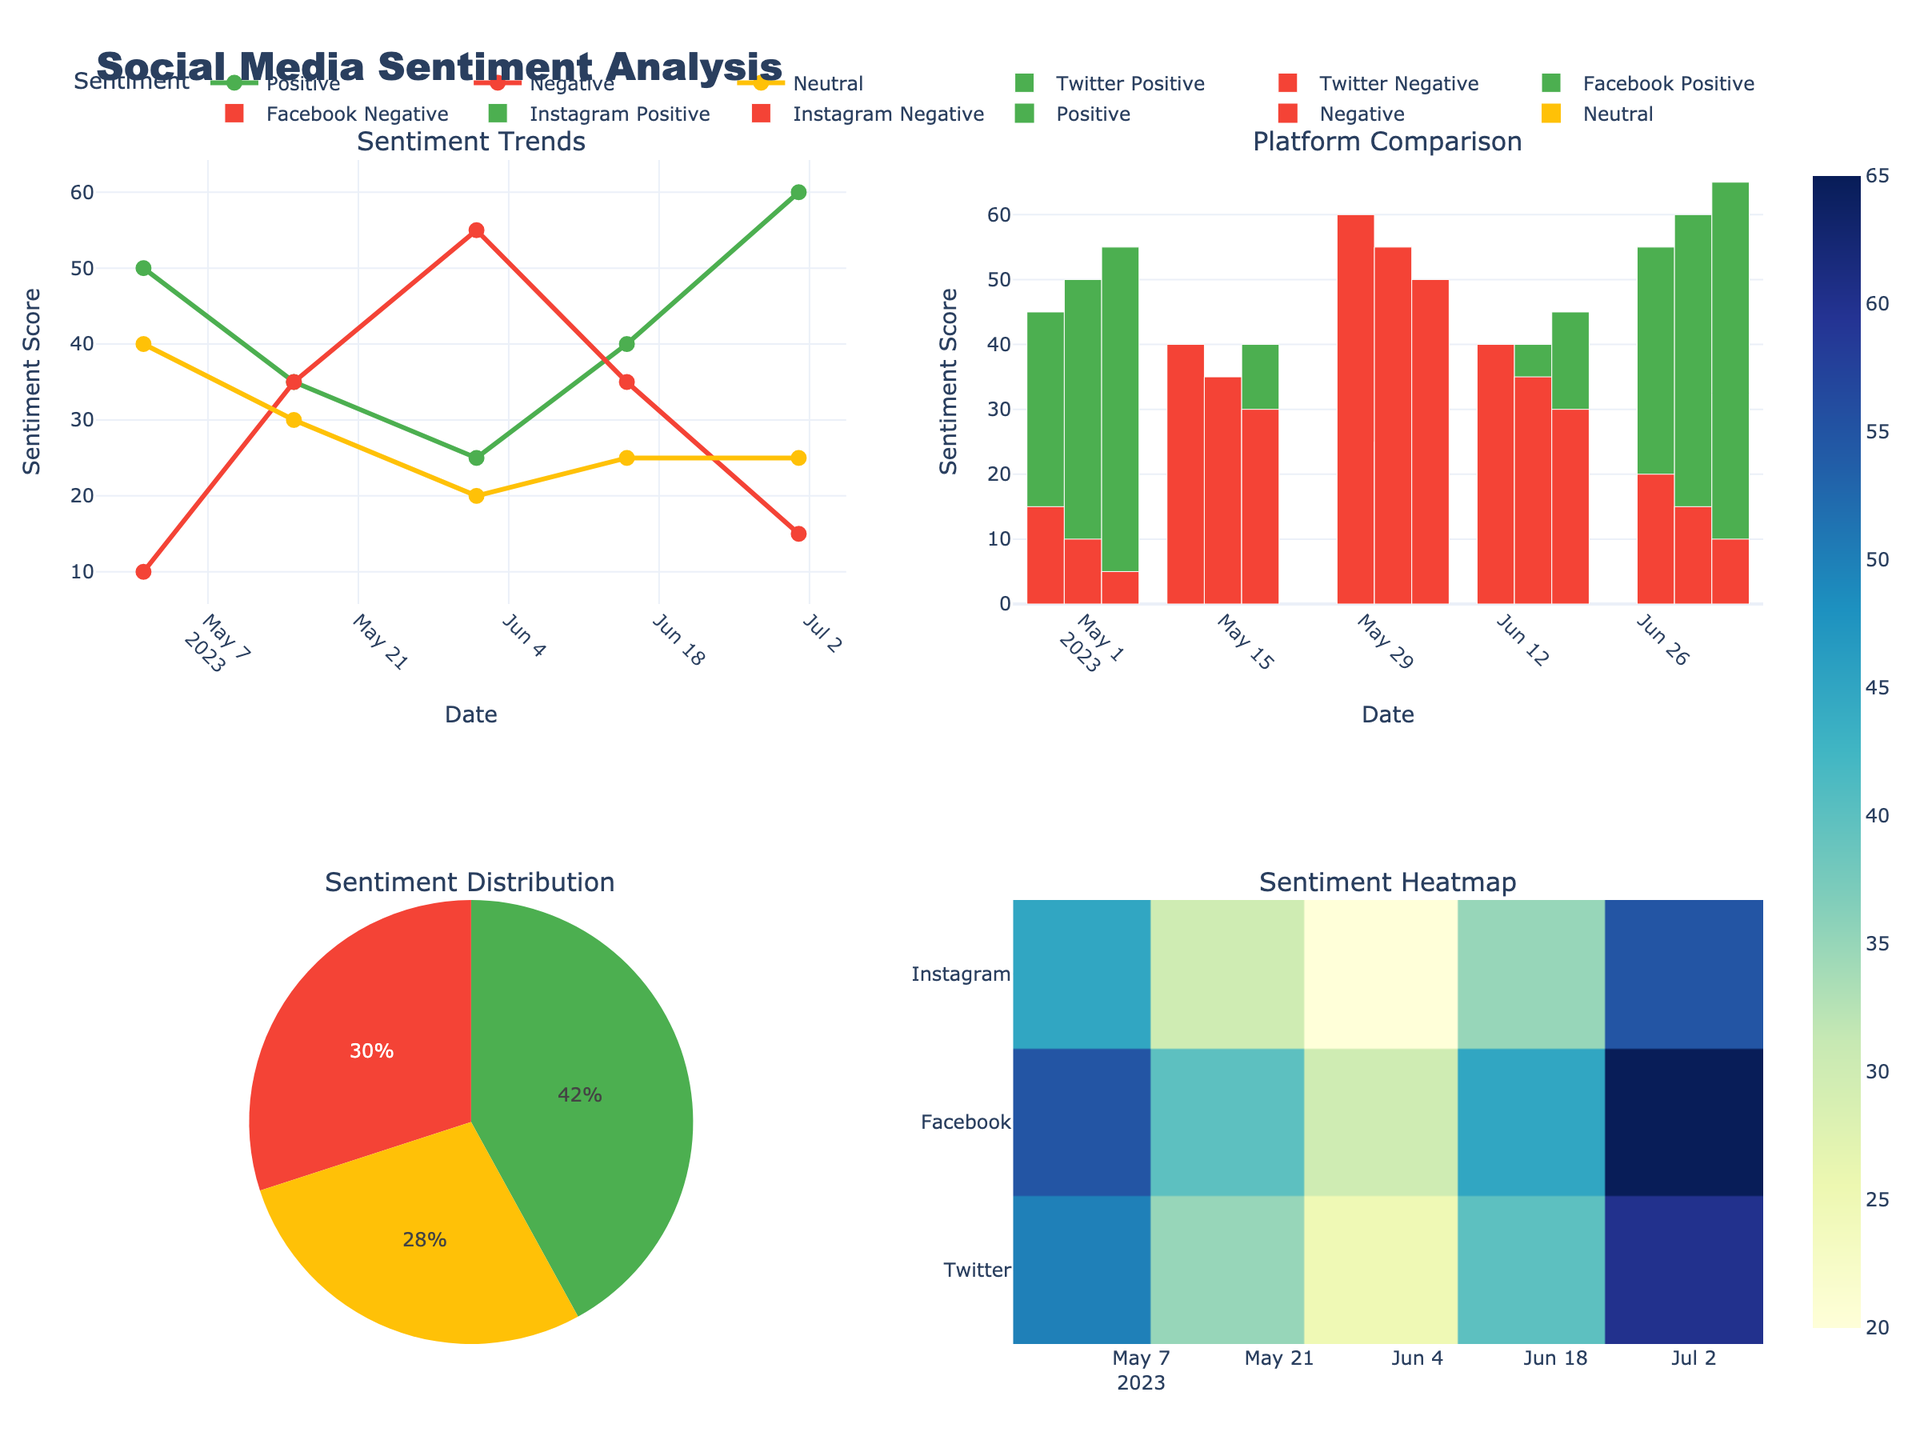What is the title of the chart? The title of the chart is placed at the top-center position and uses large, bold font for visibility.
Answer: Social Media Sentiment Analysis Which platform shows the highest positive sentiment on July 1st? Look at the grouped bar chart in the upper right corner and locate the bars corresponding to July 1st. The highest positive sentiment is indicated by the tallest blue bar among the platforms.
Answer: Instagram How did the negative sentiment on Twitter change from May 1st to June 1st? Refer to the line plot in the upper left corner. Identify the negative sentiment trend for Twitter by spotting the line color coded for negative sentiment (red). From May 1st to June 1st, the trend line shows an increase in the negative sentiment.
Answer: It increased What were the positive sentiment values for Facebook throughout the timeline? Examine the grouped bar chart in the upper right corner. Identify Facebook's positive sentiment bars and note their heights on the respective dates.
Answer: 50, 35, 25, 40, 60 Compare the overall positive sentiment on May 1st and July 1st across all platforms. Which date was higher? Refer to the line plot in the upper left corner and add up the positive sentiment values for all platforms on May 1st and July 1st. Compare the summed values.
Answer: July 1st What is the overall distribution of sentiment types? Look at the pie chart in the lower left corner. Note the proportions of each sentiment type (positive, negative, neutral) as represented by the pie slices.
Answer: Positive: largest, Negative: medium, Neutral: smallest What's the average positive sentiment across all platforms on June 15th? Locate the grouped bar chart and find the positive sentiment bars for June 15th for each platform. Sum these values: 35 (Twitter) + 40 (Facebook) + 45 (Instagram), then divide by the number of platforms (3).
Answer: 40 Which date shows the highest neutral sentiment across all platforms, and what is its value? Refer to the line plot in the upper left corner for the trend of neutral sentiment. Identify the peak point in the neutral sentiment line (yellow), and note the date and value at this peak.
Answer: May 1st, 40 How does positive sentiment on Instagram change from June 1st to June 15th? Check the grouped bar chart for the Instagram's positive sentiment in June. Observe the bar heights on June 1st and June 15th. Instagram's positive sentiment increases from 30 to 45.
Answer: It increased 